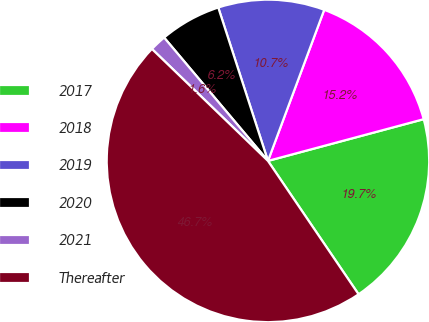<chart> <loc_0><loc_0><loc_500><loc_500><pie_chart><fcel>2017<fcel>2018<fcel>2019<fcel>2020<fcel>2021<fcel>Thereafter<nl><fcel>19.67%<fcel>15.16%<fcel>10.66%<fcel>6.15%<fcel>1.65%<fcel>46.71%<nl></chart> 